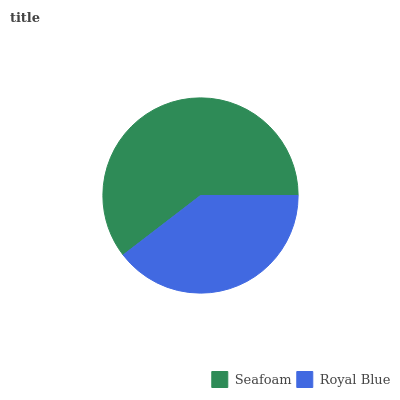Is Royal Blue the minimum?
Answer yes or no. Yes. Is Seafoam the maximum?
Answer yes or no. Yes. Is Royal Blue the maximum?
Answer yes or no. No. Is Seafoam greater than Royal Blue?
Answer yes or no. Yes. Is Royal Blue less than Seafoam?
Answer yes or no. Yes. Is Royal Blue greater than Seafoam?
Answer yes or no. No. Is Seafoam less than Royal Blue?
Answer yes or no. No. Is Seafoam the high median?
Answer yes or no. Yes. Is Royal Blue the low median?
Answer yes or no. Yes. Is Royal Blue the high median?
Answer yes or no. No. Is Seafoam the low median?
Answer yes or no. No. 